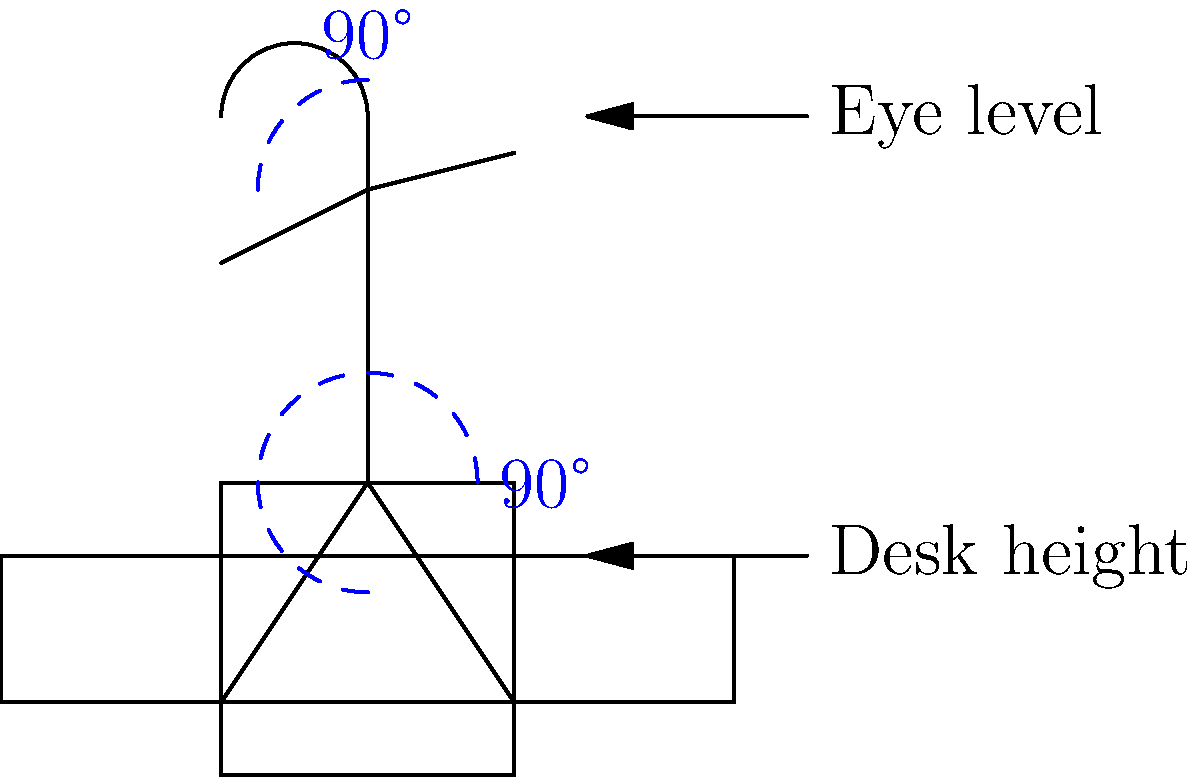Based on the diagram, which of the following statements best describes the correct posture when sitting at a desk?

A) The knees should be at a 45-degree angle
B) The back should be curved forward
C) The elbows and knees should form 90-degree angles
D) The head should be tilted downward To determine the correct posture when sitting at a desk, let's analyze the diagram step-by-step:

1. Back position: The diagram shows a straight line for the body, indicating that the back should be straight and supported by the chair.

2. Elbow angle: The right arm is positioned at a 90-degree angle, as shown by the blue dashed arc at the elbow level.

3. Knee angle: The legs are also positioned to form a 90-degree angle at the knees, as indicated by the blue dashed arc at the knee level.

4. Head position: The head is drawn in line with the body, and there's an arrow pointing to "Eye level" at the top of the screen, suggesting that the head should be upright with eyes level with the top of the screen.

5. Desk height: The desk is positioned at elbow level, allowing for a comfortable 90-degree angle of the arms.

Based on these observations, the correct posture is characterized by 90-degree angles at both the elbows and knees, a straight back, and an upright head position. This aligns with ergonomic principles that aim to reduce strain on the body during prolonged sitting.

Therefore, the statement that best describes the correct posture shown in the diagram is option C: The elbows and knees should form 90-degree angles.
Answer: C) The elbows and knees should form 90-degree angles 